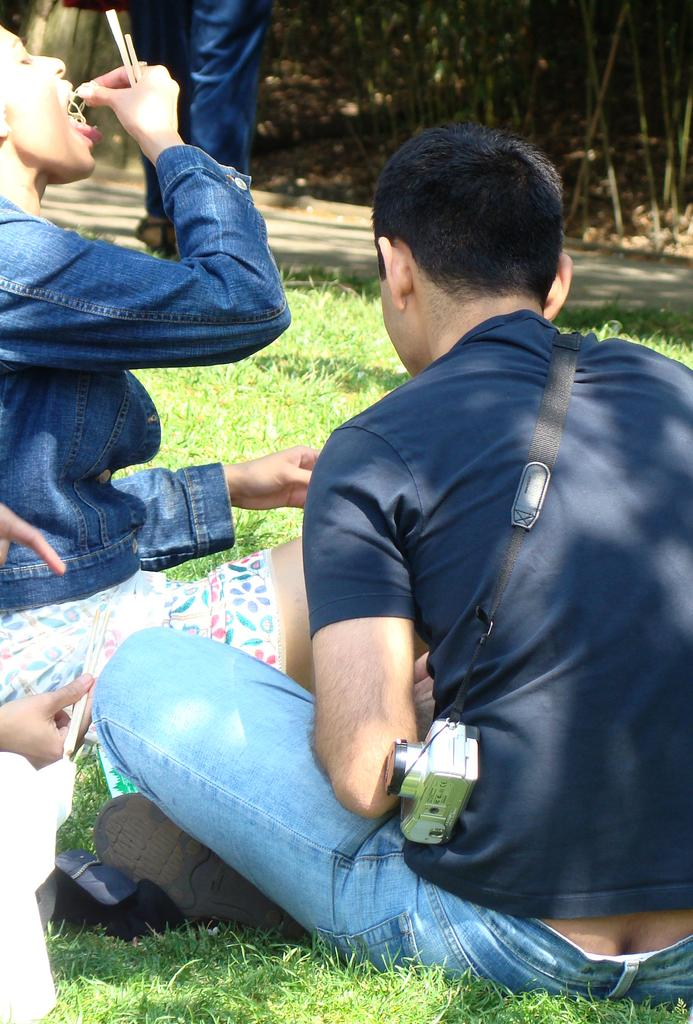What are the people in the image doing? The people in the image are sitting on the grass. Are there any people standing in the image? Yes, there is a person standing in the image. What else can be seen in the image besides people? There is a road visible in the image. What type of muscle is being flexed by the person standing in the image? There is no indication in the image that the person standing is flexing any muscles. How many chins does the person standing have in the image? The image does not provide enough detail to determine the number of chins the person standing has. 